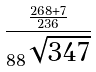<formula> <loc_0><loc_0><loc_500><loc_500>\frac { \frac { 2 6 8 + 7 } { 2 3 6 } } { 8 8 ^ { \sqrt { 3 4 7 } } }</formula> 